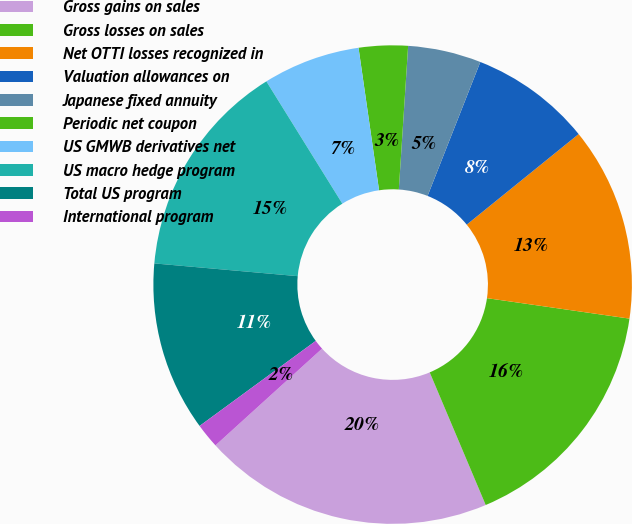<chart> <loc_0><loc_0><loc_500><loc_500><pie_chart><fcel>Gross gains on sales<fcel>Gross losses on sales<fcel>Net OTTI losses recognized in<fcel>Valuation allowances on<fcel>Japanese fixed annuity<fcel>Periodic net coupon<fcel>US GMWB derivatives net<fcel>US macro hedge program<fcel>Total US program<fcel>International program<nl><fcel>19.63%<fcel>16.37%<fcel>13.1%<fcel>8.2%<fcel>4.94%<fcel>3.31%<fcel>6.57%<fcel>14.74%<fcel>11.47%<fcel>1.67%<nl></chart> 